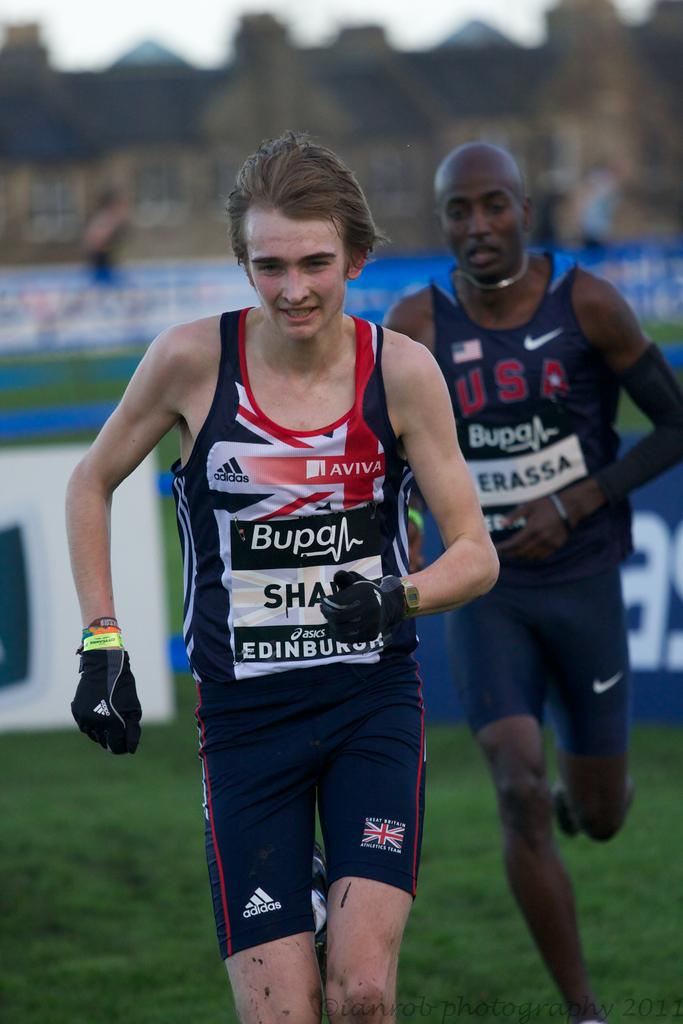<image>
Summarize the visual content of the image. a person running with Bupa written on their outfit 